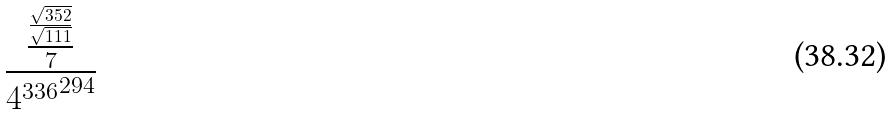<formula> <loc_0><loc_0><loc_500><loc_500>\frac { \frac { \frac { \sqrt { 3 5 2 } } { \sqrt { 1 1 1 } } } { 7 } } { { 4 ^ { 3 3 6 } } ^ { 2 9 4 } }</formula> 